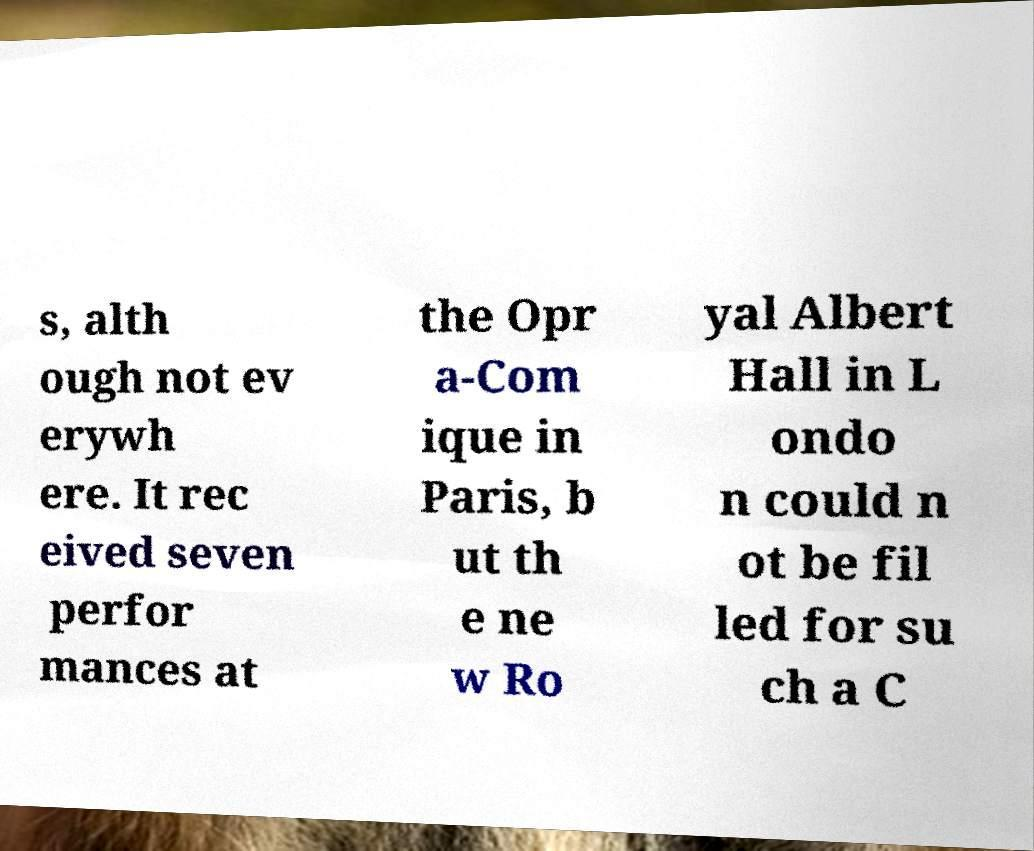I need the written content from this picture converted into text. Can you do that? s, alth ough not ev erywh ere. It rec eived seven perfor mances at the Opr a-Com ique in Paris, b ut th e ne w Ro yal Albert Hall in L ondo n could n ot be fil led for su ch a C 